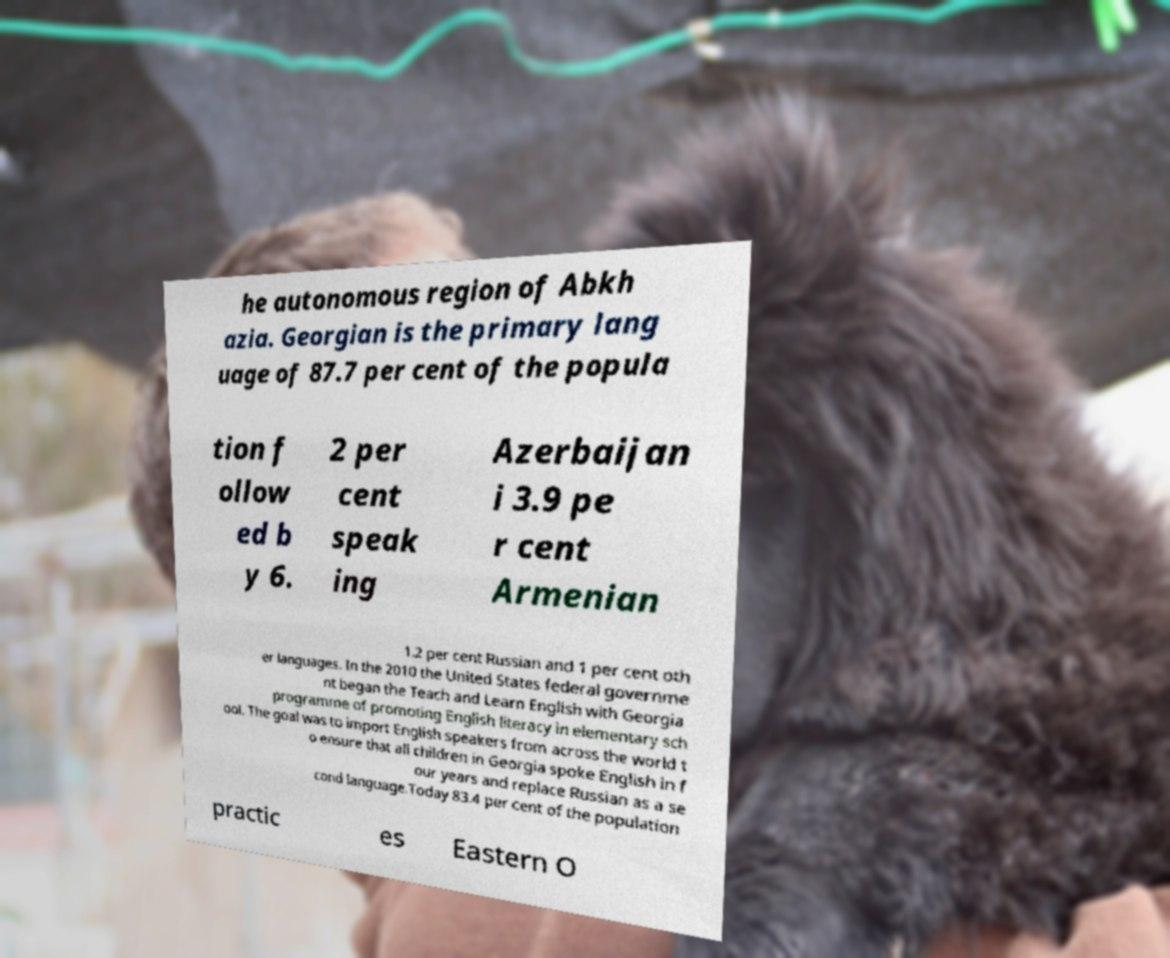What messages or text are displayed in this image? I need them in a readable, typed format. he autonomous region of Abkh azia. Georgian is the primary lang uage of 87.7 per cent of the popula tion f ollow ed b y 6. 2 per cent speak ing Azerbaijan i 3.9 pe r cent Armenian 1.2 per cent Russian and 1 per cent oth er languages. In the 2010 the United States federal governme nt began the Teach and Learn English with Georgia programme of promoting English literacy in elementary sch ool. The goal was to import English speakers from across the world t o ensure that all children in Georgia spoke English in f our years and replace Russian as a se cond language.Today 83.4 per cent of the population practic es Eastern O 